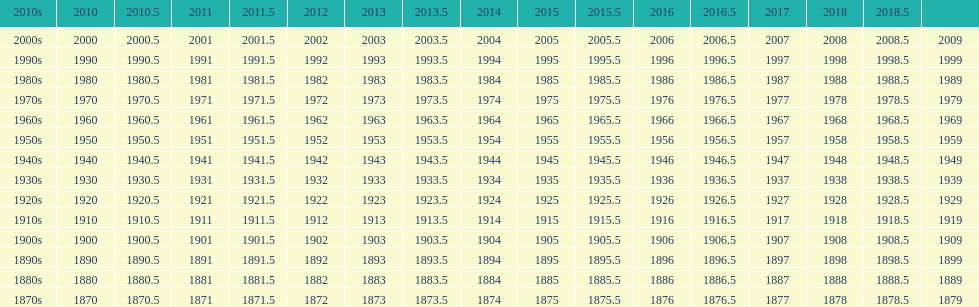What year is after 2018, but does not have a place on the table? 2019. 